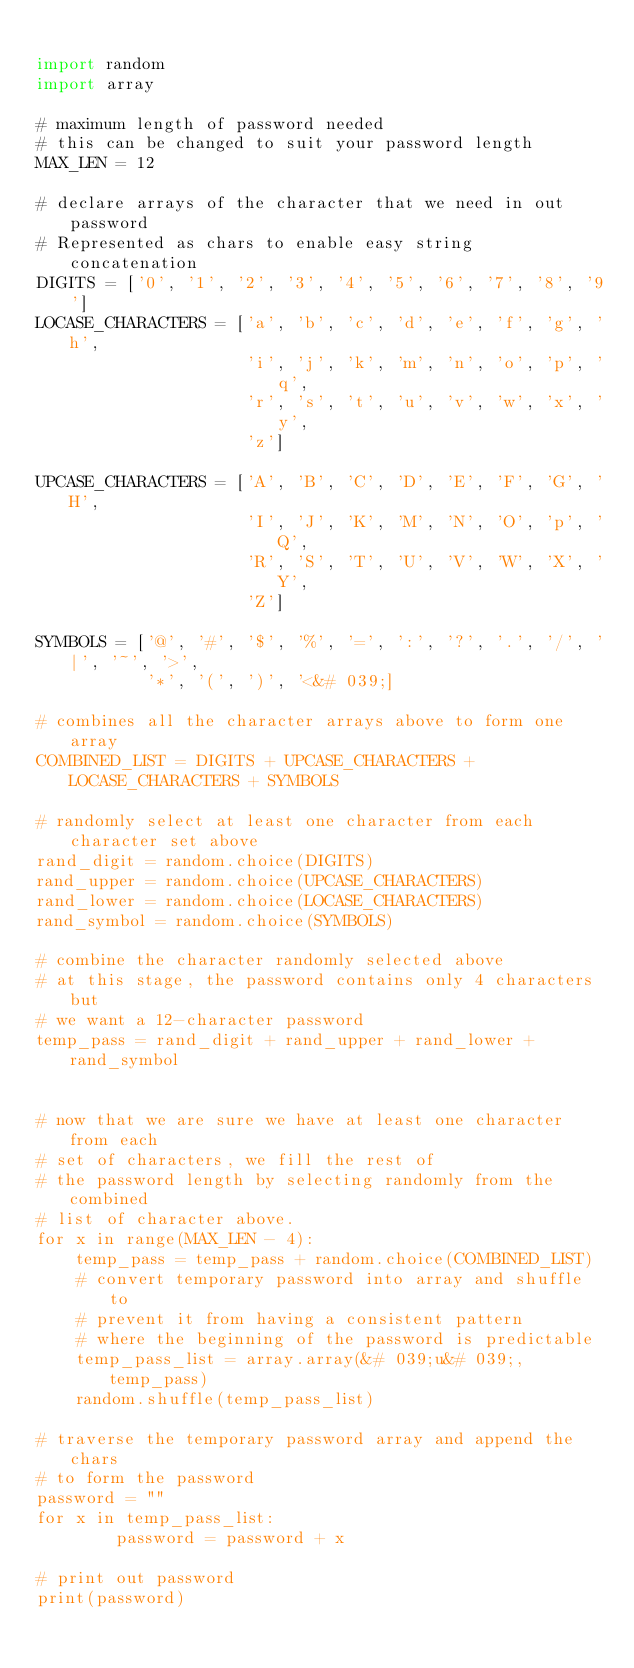<code> <loc_0><loc_0><loc_500><loc_500><_Python_>
import random 
import array 
  
# maximum length of password needed 
# this can be changed to suit your password length 
MAX_LEN = 12
  
# declare arrays of the character that we need in out password 
# Represented as chars to enable easy string concatenation 
DIGITS = ['0', '1', '2', '3', '4', '5', '6', '7', '8', '9']   
LOCASE_CHARACTERS = ['a', 'b', 'c', 'd', 'e', 'f', 'g', 'h',  
                     'i', 'j', 'k', 'm', 'n', 'o', 'p', 'q', 
                     'r', 's', 't', 'u', 'v', 'w', 'x', 'y', 
                     'z'] 
  
UPCASE_CHARACTERS = ['A', 'B', 'C', 'D', 'E', 'F', 'G', 'H',  
                     'I', 'J', 'K', 'M', 'N', 'O', 'p', 'Q', 
                     'R', 'S', 'T', 'U', 'V', 'W', 'X', 'Y', 
                     'Z'] 
  
SYMBOLS = ['@', '#', '$', '%', '=', ':', '?', '.', '/', '|', '~', '>',  
           '*', '(', ')', '<&# 039;] 
  
# combines all the character arrays above to form one array 
COMBINED_LIST = DIGITS + UPCASE_CHARACTERS + LOCASE_CHARACTERS + SYMBOLS 
  
# randomly select at least one character from each character set above 
rand_digit = random.choice(DIGITS) 
rand_upper = random.choice(UPCASE_CHARACTERS) 
rand_lower = random.choice(LOCASE_CHARACTERS) 
rand_symbol = random.choice(SYMBOLS) 
  
# combine the character randomly selected above 
# at this stage, the password contains only 4 characters but  
# we want a 12-character password 
temp_pass = rand_digit + rand_upper + rand_lower + rand_symbol 
  
  
# now that we are sure we have at least one character from each 
# set of characters, we fill the rest of 
# the password length by selecting randomly from the combined  
# list of character above. 
for x in range(MAX_LEN - 4): 
    temp_pass = temp_pass + random.choice(COMBINED_LIST) 
    # convert temporary password into array and shuffle to  
    # prevent it from having a consistent pattern 
    # where the beginning of the password is predictable 
    temp_pass_list = array.array(&# 039;u&# 039;, temp_pass) 
    random.shuffle(temp_pass_list) 
  
# traverse the temporary password array and append the chars 
# to form the password 
password = "" 
for x in temp_pass_list: 
        password = password + x 
          
# print out password 
print(password) 
</code> 